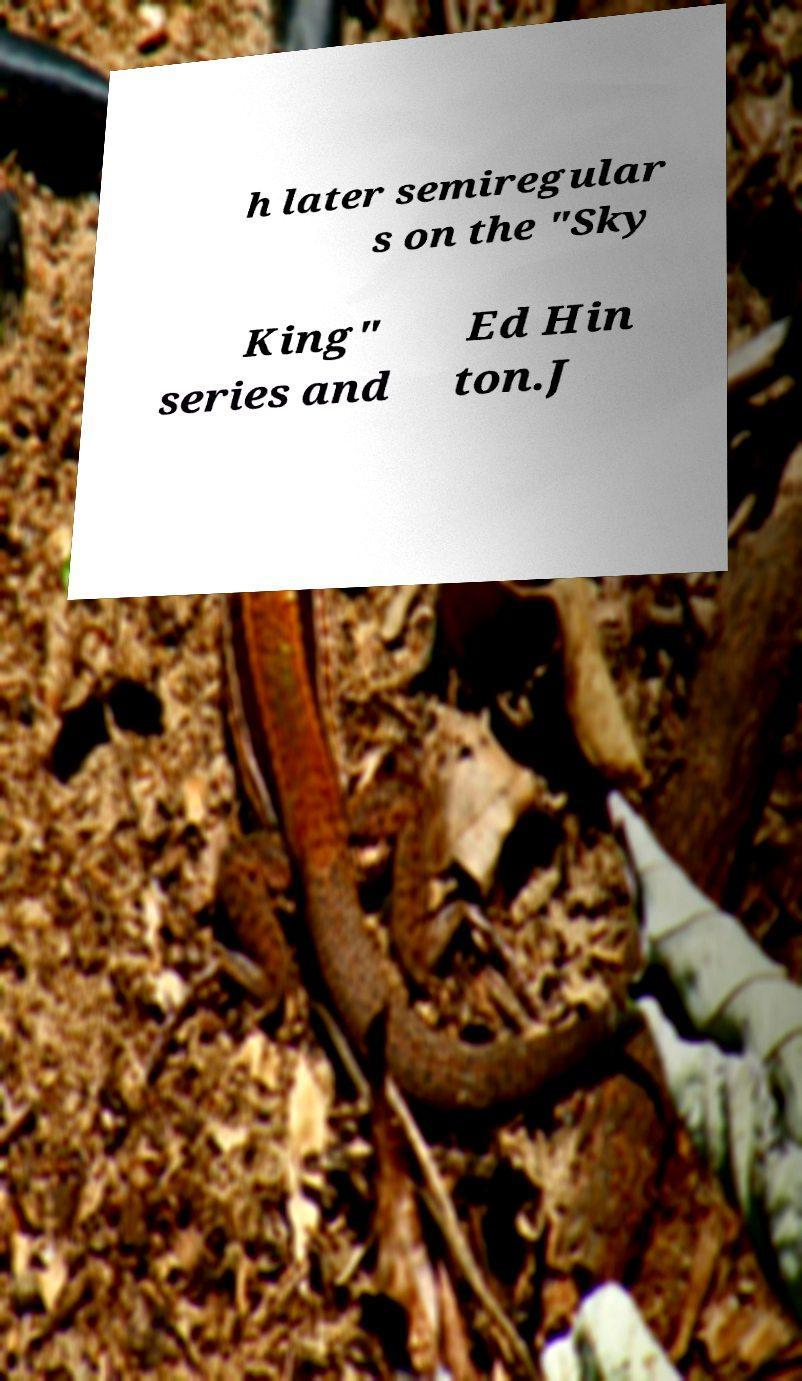Can you read and provide the text displayed in the image?This photo seems to have some interesting text. Can you extract and type it out for me? h later semiregular s on the "Sky King" series and Ed Hin ton.J 